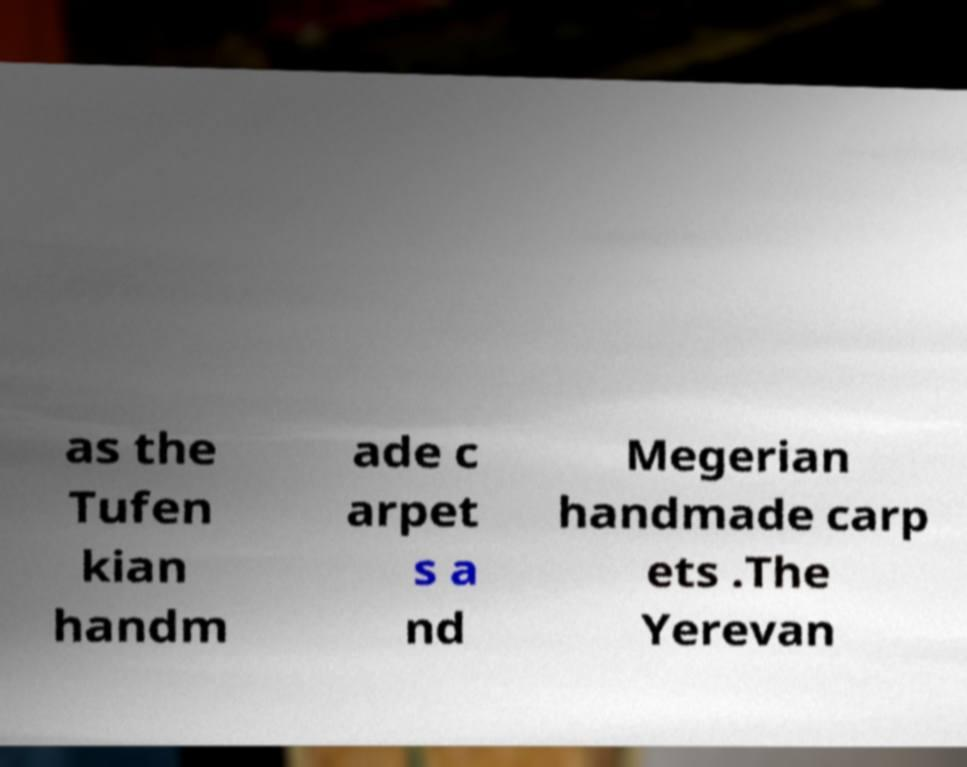Can you read and provide the text displayed in the image?This photo seems to have some interesting text. Can you extract and type it out for me? as the Tufen kian handm ade c arpet s a nd Megerian handmade carp ets .The Yerevan 